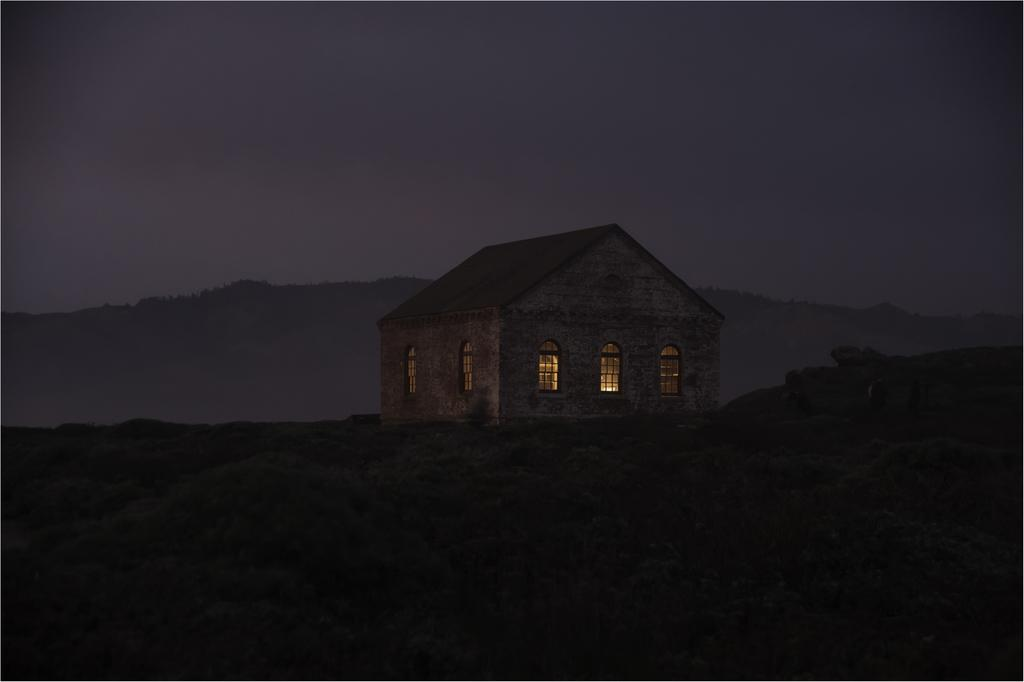What type of structure is in the image? There is a building with windows in the image. Where is the building located? The building is on a hill. What else can be seen in the background of the image? There is a hill and the sky visible in the background of the image. What type of behavior can be observed in the building's pocket in the image? There is no mention of a pocket in the building or any behavior associated with it in the image. 